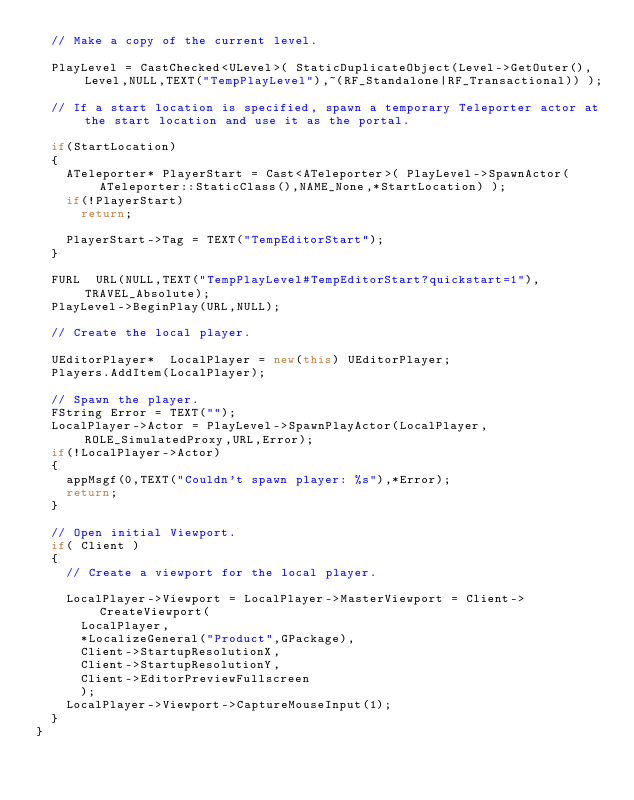<code> <loc_0><loc_0><loc_500><loc_500><_C++_>	// Make a copy of the current level.

	PlayLevel = CastChecked<ULevel>( StaticDuplicateObject(Level->GetOuter(),Level,NULL,TEXT("TempPlayLevel"),~(RF_Standalone|RF_Transactional)) );

	// If a start location is specified, spawn a temporary Teleporter actor at the start location and use it as the portal.

	if(StartLocation)
	{
		ATeleporter* PlayerStart = Cast<ATeleporter>( PlayLevel->SpawnActor(ATeleporter::StaticClass(),NAME_None,*StartLocation) );
		if(!PlayerStart)
			return;

		PlayerStart->Tag = TEXT("TempEditorStart");
	}

	FURL	URL(NULL,TEXT("TempPlayLevel#TempEditorStart?quickstart=1"),TRAVEL_Absolute);
	PlayLevel->BeginPlay(URL,NULL);

	// Create the local player.

	UEditorPlayer*	LocalPlayer = new(this) UEditorPlayer;
	Players.AddItem(LocalPlayer);

	// Spawn the player.
	FString	Error = TEXT("");
	LocalPlayer->Actor = PlayLevel->SpawnPlayActor(LocalPlayer,ROLE_SimulatedProxy,URL,Error);
	if(!LocalPlayer->Actor)
	{
		appMsgf(0,TEXT("Couldn't spawn player: %s"),*Error);
		return;
	}

	// Open initial Viewport.
	if( Client )
	{
		// Create a viewport for the local player.

		LocalPlayer->Viewport = LocalPlayer->MasterViewport = Client->CreateViewport(
			LocalPlayer,
			*LocalizeGeneral("Product",GPackage),
			Client->StartupResolutionX,
			Client->StartupResolutionY,
			Client->EditorPreviewFullscreen
			);
		LocalPlayer->Viewport->CaptureMouseInput(1);
	}
}
</code> 